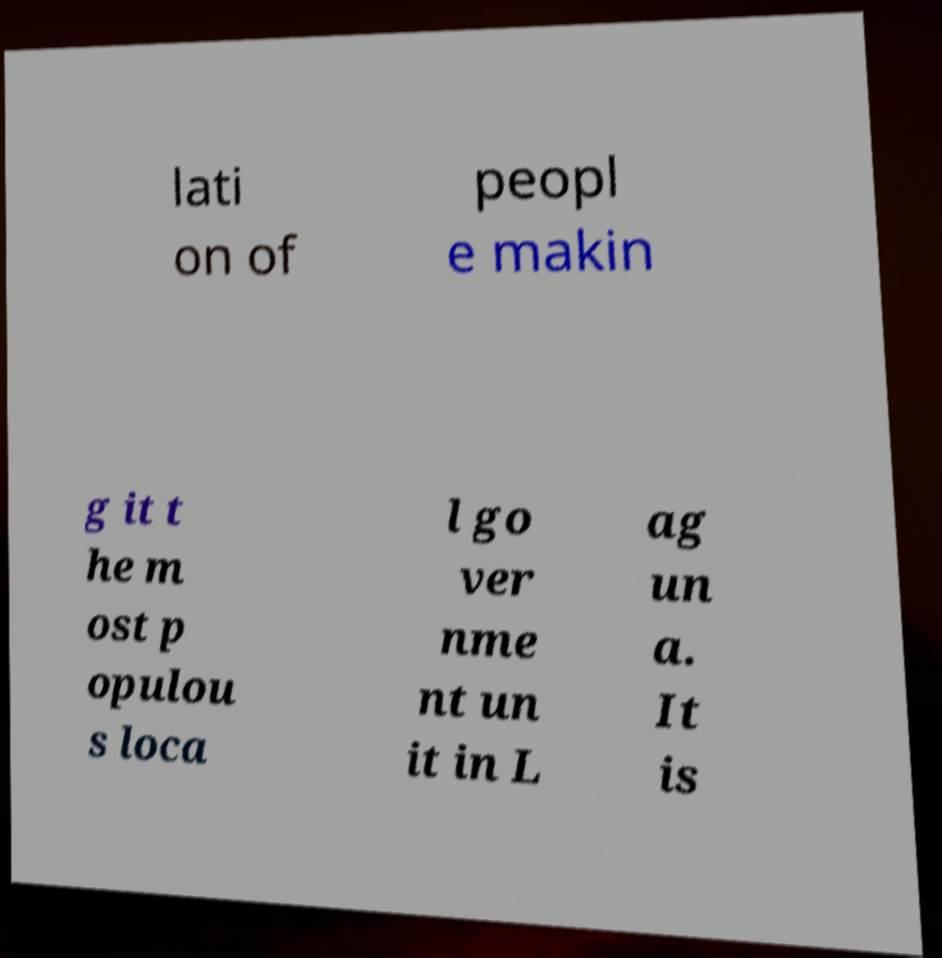There's text embedded in this image that I need extracted. Can you transcribe it verbatim? lati on of peopl e makin g it t he m ost p opulou s loca l go ver nme nt un it in L ag un a. It is 